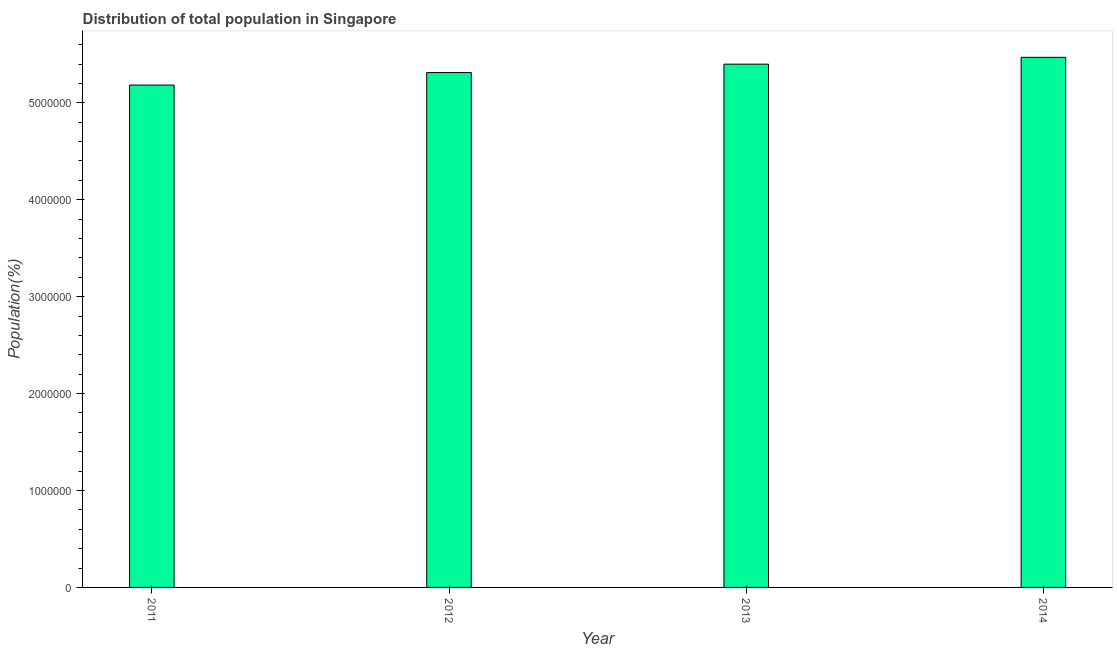Does the graph contain grids?
Your answer should be compact. No. What is the title of the graph?
Give a very brief answer. Distribution of total population in Singapore . What is the label or title of the X-axis?
Ensure brevity in your answer.  Year. What is the label or title of the Y-axis?
Give a very brief answer. Population(%). What is the population in 2014?
Ensure brevity in your answer.  5.47e+06. Across all years, what is the maximum population?
Ensure brevity in your answer.  5.47e+06. Across all years, what is the minimum population?
Offer a very short reply. 5.18e+06. In which year was the population minimum?
Your answer should be compact. 2011. What is the sum of the population?
Give a very brief answer. 2.14e+07. What is the difference between the population in 2013 and 2014?
Make the answer very short. -7.05e+04. What is the average population per year?
Make the answer very short. 5.34e+06. What is the median population?
Give a very brief answer. 5.36e+06. Do a majority of the years between 2011 and 2013 (inclusive) have population greater than 800000 %?
Your answer should be very brief. Yes. Is the population in 2012 less than that in 2014?
Your answer should be very brief. Yes. Is the difference between the population in 2011 and 2012 greater than the difference between any two years?
Ensure brevity in your answer.  No. What is the difference between the highest and the second highest population?
Keep it short and to the point. 7.05e+04. Is the sum of the population in 2011 and 2014 greater than the maximum population across all years?
Ensure brevity in your answer.  Yes. What is the difference between the highest and the lowest population?
Give a very brief answer. 2.86e+05. How many bars are there?
Provide a short and direct response. 4. Are all the bars in the graph horizontal?
Provide a short and direct response. No. What is the Population(%) of 2011?
Your response must be concise. 5.18e+06. What is the Population(%) of 2012?
Offer a very short reply. 5.31e+06. What is the Population(%) in 2013?
Offer a terse response. 5.40e+06. What is the Population(%) in 2014?
Provide a short and direct response. 5.47e+06. What is the difference between the Population(%) in 2011 and 2012?
Provide a succinct answer. -1.29e+05. What is the difference between the Population(%) in 2011 and 2013?
Provide a short and direct response. -2.16e+05. What is the difference between the Population(%) in 2011 and 2014?
Ensure brevity in your answer.  -2.86e+05. What is the difference between the Population(%) in 2012 and 2013?
Your response must be concise. -8.68e+04. What is the difference between the Population(%) in 2012 and 2014?
Your response must be concise. -1.57e+05. What is the difference between the Population(%) in 2013 and 2014?
Your answer should be very brief. -7.05e+04. What is the ratio of the Population(%) in 2011 to that in 2012?
Your answer should be very brief. 0.98. What is the ratio of the Population(%) in 2011 to that in 2014?
Offer a terse response. 0.95. What is the ratio of the Population(%) in 2012 to that in 2014?
Provide a succinct answer. 0.97. What is the ratio of the Population(%) in 2013 to that in 2014?
Ensure brevity in your answer.  0.99. 